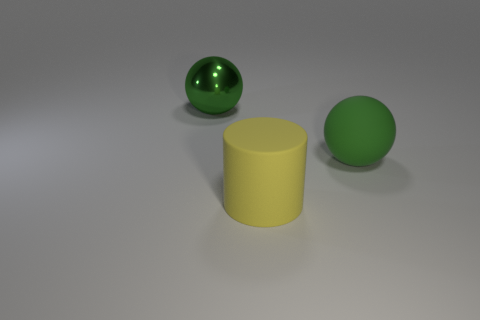Add 2 blue metallic cylinders. How many objects exist? 5 Subtract all cylinders. How many objects are left? 2 Subtract 1 cylinders. How many cylinders are left? 0 Add 1 large green shiny spheres. How many large green shiny spheres exist? 2 Subtract 0 green blocks. How many objects are left? 3 Subtract all blue balls. Subtract all red cylinders. How many balls are left? 2 Subtract all big yellow matte objects. Subtract all large green shiny things. How many objects are left? 1 Add 3 matte spheres. How many matte spheres are left? 4 